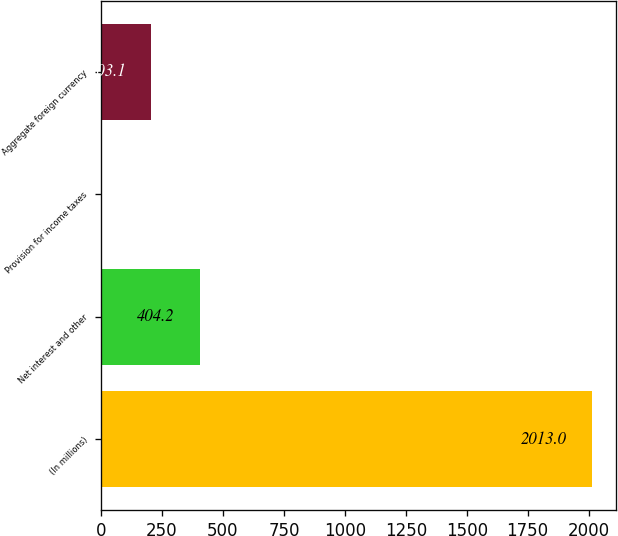Convert chart. <chart><loc_0><loc_0><loc_500><loc_500><bar_chart><fcel>(In millions)<fcel>Net interest and other<fcel>Provision for income taxes<fcel>Aggregate foreign currency<nl><fcel>2013<fcel>404.2<fcel>2<fcel>203.1<nl></chart> 